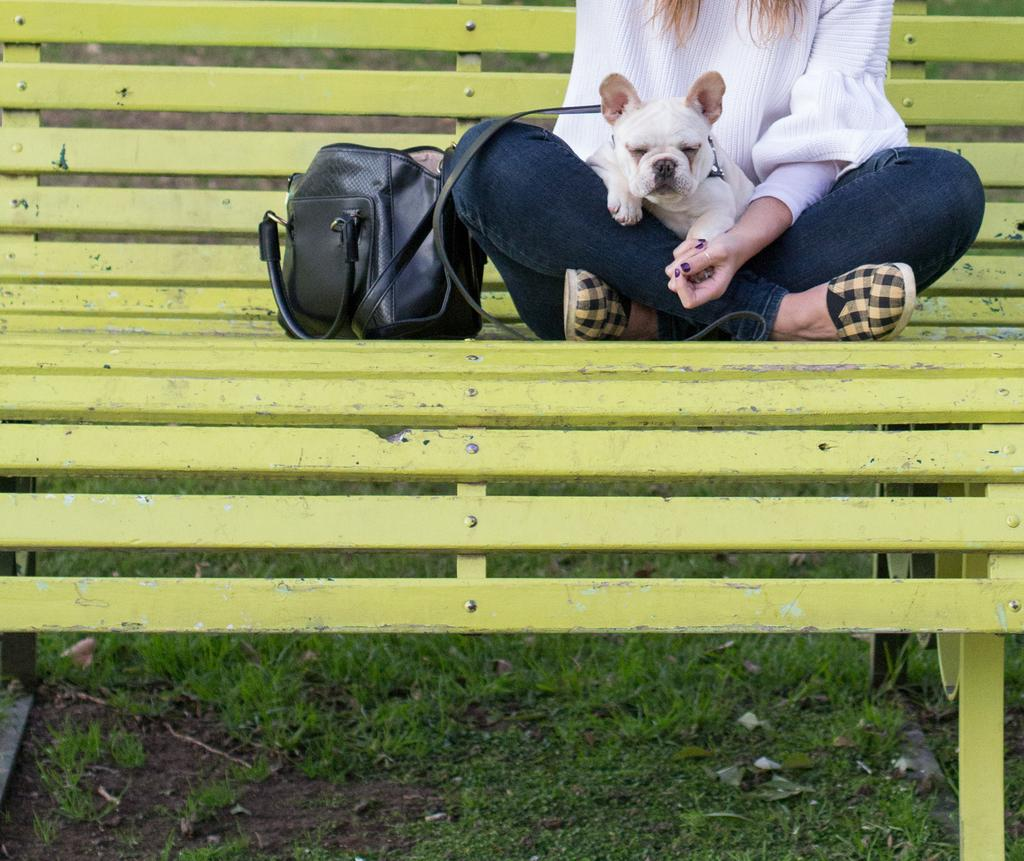What is the person in the image doing? The person is sitting on a bench in the image. What is the person holding or interacting with on the bench? The person has a dog in her lap. Is there any personal belonging or item near the person? Yes, there is a bag beside the person. How many chairs are visible in the image? There are no chairs visible in the image, only a bench. Is there a glass of water on the bench? There is no glass of water present in the image. 